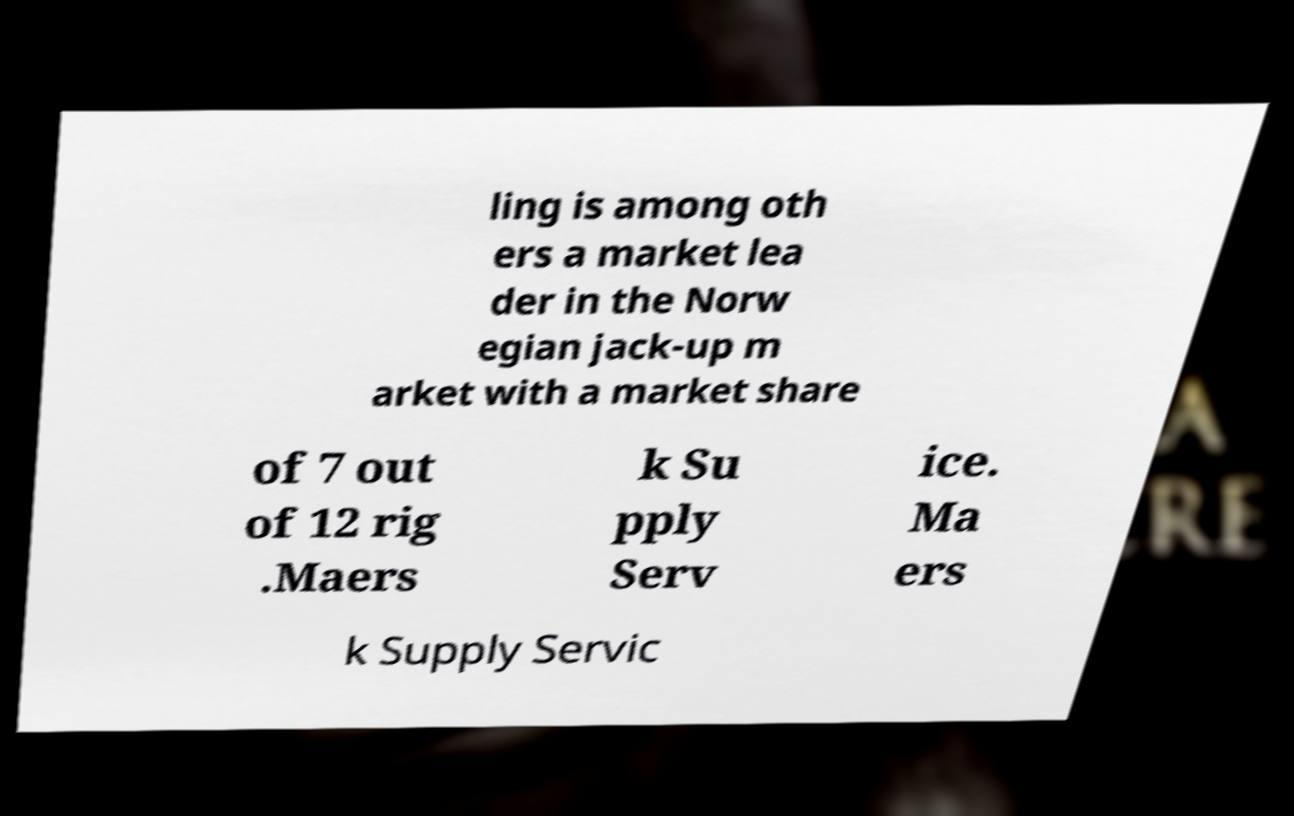What messages or text are displayed in this image? I need them in a readable, typed format. ling is among oth ers a market lea der in the Norw egian jack-up m arket with a market share of 7 out of 12 rig .Maers k Su pply Serv ice. Ma ers k Supply Servic 